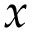<formula> <loc_0><loc_0><loc_500><loc_500>x</formula> 